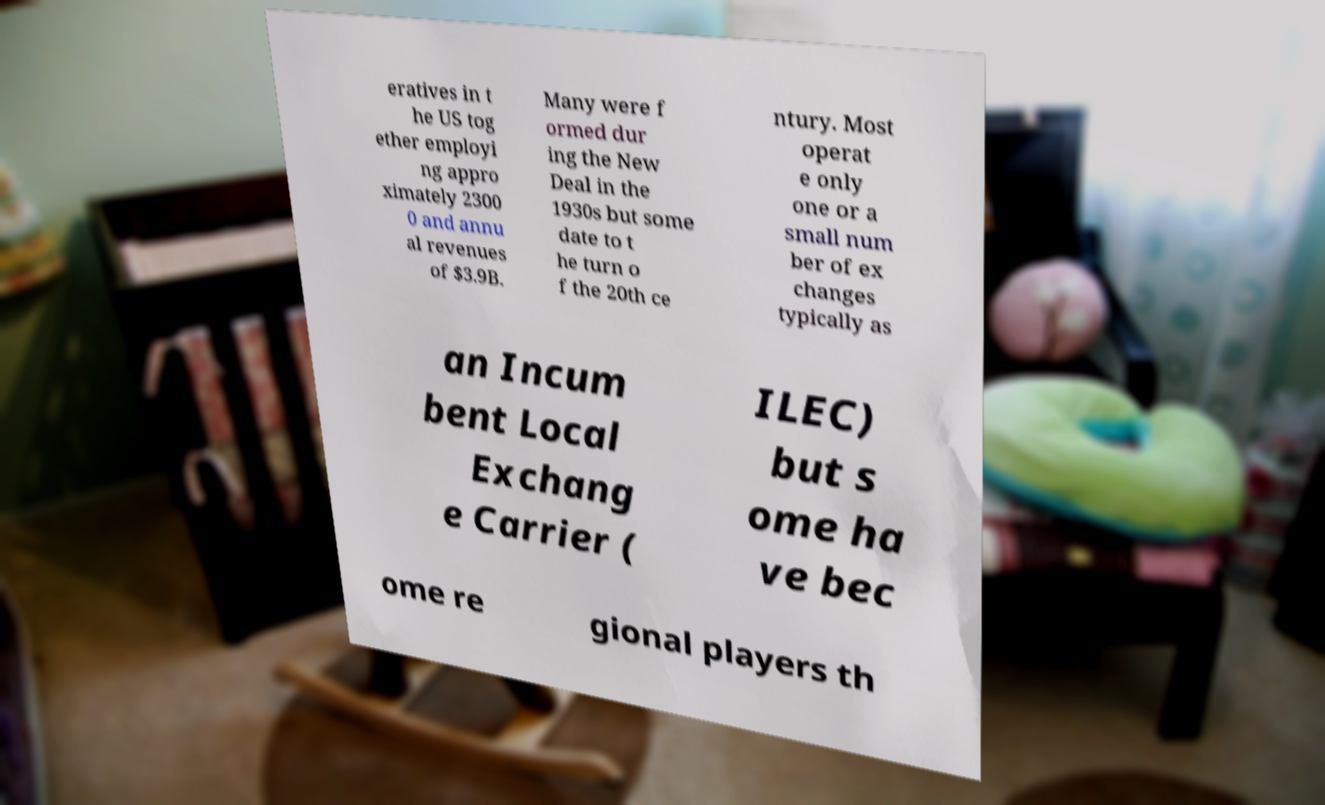I need the written content from this picture converted into text. Can you do that? eratives in t he US tog ether employi ng appro ximately 2300 0 and annu al revenues of $3.9B. Many were f ormed dur ing the New Deal in the 1930s but some date to t he turn o f the 20th ce ntury. Most operat e only one or a small num ber of ex changes typically as an Incum bent Local Exchang e Carrier ( ILEC) but s ome ha ve bec ome re gional players th 